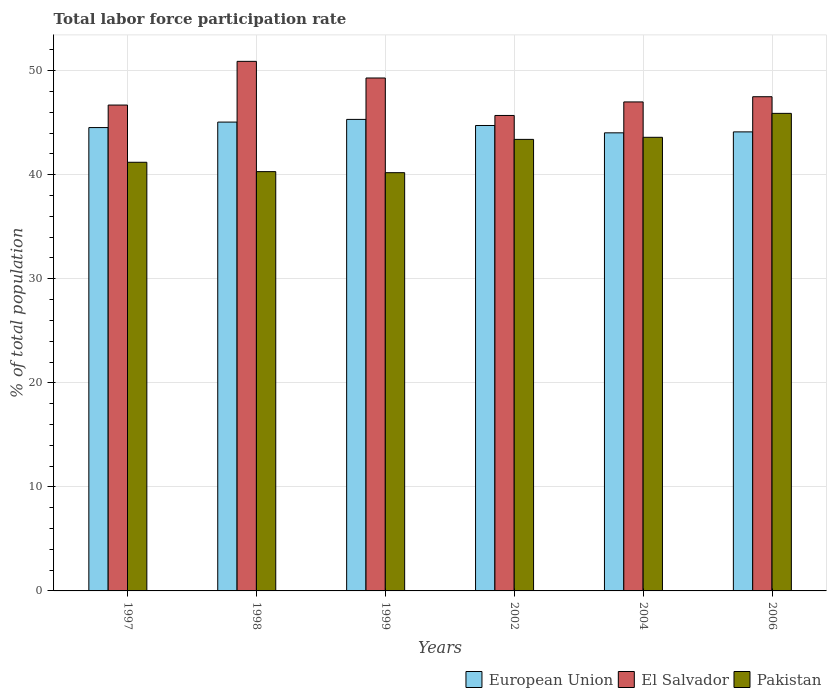Are the number of bars per tick equal to the number of legend labels?
Provide a succinct answer. Yes. How many bars are there on the 2nd tick from the left?
Keep it short and to the point. 3. What is the label of the 5th group of bars from the left?
Ensure brevity in your answer.  2004. In how many cases, is the number of bars for a given year not equal to the number of legend labels?
Offer a terse response. 0. What is the total labor force participation rate in European Union in 1999?
Ensure brevity in your answer.  45.32. Across all years, what is the maximum total labor force participation rate in El Salvador?
Give a very brief answer. 50.9. Across all years, what is the minimum total labor force participation rate in El Salvador?
Ensure brevity in your answer.  45.7. In which year was the total labor force participation rate in Pakistan minimum?
Give a very brief answer. 1999. What is the total total labor force participation rate in El Salvador in the graph?
Give a very brief answer. 287.1. What is the difference between the total labor force participation rate in Pakistan in 1997 and that in 1998?
Provide a short and direct response. 0.9. What is the difference between the total labor force participation rate in Pakistan in 2006 and the total labor force participation rate in European Union in 2004?
Provide a succinct answer. 1.87. What is the average total labor force participation rate in Pakistan per year?
Offer a very short reply. 42.43. In the year 1998, what is the difference between the total labor force participation rate in El Salvador and total labor force participation rate in European Union?
Provide a short and direct response. 5.84. In how many years, is the total labor force participation rate in El Salvador greater than 32 %?
Offer a very short reply. 6. What is the ratio of the total labor force participation rate in Pakistan in 1997 to that in 1998?
Keep it short and to the point. 1.02. Is the difference between the total labor force participation rate in El Salvador in 1998 and 1999 greater than the difference between the total labor force participation rate in European Union in 1998 and 1999?
Offer a very short reply. Yes. What is the difference between the highest and the second highest total labor force participation rate in European Union?
Make the answer very short. 0.26. What is the difference between the highest and the lowest total labor force participation rate in El Salvador?
Your response must be concise. 5.2. In how many years, is the total labor force participation rate in European Union greater than the average total labor force participation rate in European Union taken over all years?
Offer a very short reply. 3. Is the sum of the total labor force participation rate in El Salvador in 1999 and 2006 greater than the maximum total labor force participation rate in Pakistan across all years?
Make the answer very short. Yes. What does the 3rd bar from the left in 2004 represents?
Offer a terse response. Pakistan. What does the 2nd bar from the right in 2006 represents?
Provide a short and direct response. El Salvador. How many bars are there?
Provide a short and direct response. 18. Are the values on the major ticks of Y-axis written in scientific E-notation?
Provide a succinct answer. No. Does the graph contain any zero values?
Give a very brief answer. No. Does the graph contain grids?
Provide a succinct answer. Yes. How are the legend labels stacked?
Provide a short and direct response. Horizontal. What is the title of the graph?
Offer a terse response. Total labor force participation rate. What is the label or title of the Y-axis?
Make the answer very short. % of total population. What is the % of total population of European Union in 1997?
Make the answer very short. 44.54. What is the % of total population of El Salvador in 1997?
Your response must be concise. 46.7. What is the % of total population of Pakistan in 1997?
Provide a succinct answer. 41.2. What is the % of total population in European Union in 1998?
Keep it short and to the point. 45.06. What is the % of total population in El Salvador in 1998?
Offer a terse response. 50.9. What is the % of total population in Pakistan in 1998?
Your response must be concise. 40.3. What is the % of total population in European Union in 1999?
Offer a terse response. 45.32. What is the % of total population in El Salvador in 1999?
Provide a succinct answer. 49.3. What is the % of total population in Pakistan in 1999?
Make the answer very short. 40.2. What is the % of total population of European Union in 2002?
Your answer should be very brief. 44.74. What is the % of total population of El Salvador in 2002?
Your response must be concise. 45.7. What is the % of total population in Pakistan in 2002?
Ensure brevity in your answer.  43.4. What is the % of total population in European Union in 2004?
Offer a terse response. 44.03. What is the % of total population in Pakistan in 2004?
Give a very brief answer. 43.6. What is the % of total population in European Union in 2006?
Keep it short and to the point. 44.12. What is the % of total population of El Salvador in 2006?
Your answer should be very brief. 47.5. What is the % of total population of Pakistan in 2006?
Keep it short and to the point. 45.9. Across all years, what is the maximum % of total population in European Union?
Your response must be concise. 45.32. Across all years, what is the maximum % of total population of El Salvador?
Provide a succinct answer. 50.9. Across all years, what is the maximum % of total population of Pakistan?
Offer a very short reply. 45.9. Across all years, what is the minimum % of total population in European Union?
Provide a short and direct response. 44.03. Across all years, what is the minimum % of total population in El Salvador?
Provide a short and direct response. 45.7. Across all years, what is the minimum % of total population in Pakistan?
Provide a succinct answer. 40.2. What is the total % of total population of European Union in the graph?
Your answer should be compact. 267.81. What is the total % of total population of El Salvador in the graph?
Ensure brevity in your answer.  287.1. What is the total % of total population in Pakistan in the graph?
Give a very brief answer. 254.6. What is the difference between the % of total population in European Union in 1997 and that in 1998?
Your answer should be very brief. -0.53. What is the difference between the % of total population in El Salvador in 1997 and that in 1998?
Offer a very short reply. -4.2. What is the difference between the % of total population of European Union in 1997 and that in 1999?
Give a very brief answer. -0.79. What is the difference between the % of total population in European Union in 1997 and that in 2002?
Provide a succinct answer. -0.2. What is the difference between the % of total population of El Salvador in 1997 and that in 2002?
Offer a terse response. 1. What is the difference between the % of total population of European Union in 1997 and that in 2004?
Ensure brevity in your answer.  0.51. What is the difference between the % of total population in European Union in 1997 and that in 2006?
Your answer should be compact. 0.42. What is the difference between the % of total population in El Salvador in 1997 and that in 2006?
Keep it short and to the point. -0.8. What is the difference between the % of total population in Pakistan in 1997 and that in 2006?
Provide a short and direct response. -4.7. What is the difference between the % of total population of European Union in 1998 and that in 1999?
Ensure brevity in your answer.  -0.26. What is the difference between the % of total population of Pakistan in 1998 and that in 1999?
Offer a very short reply. 0.1. What is the difference between the % of total population of European Union in 1998 and that in 2002?
Your answer should be compact. 0.33. What is the difference between the % of total population of El Salvador in 1998 and that in 2002?
Make the answer very short. 5.2. What is the difference between the % of total population of European Union in 1998 and that in 2004?
Give a very brief answer. 1.03. What is the difference between the % of total population in Pakistan in 1998 and that in 2004?
Provide a succinct answer. -3.3. What is the difference between the % of total population in European Union in 1998 and that in 2006?
Your answer should be compact. 0.94. What is the difference between the % of total population in Pakistan in 1998 and that in 2006?
Offer a terse response. -5.6. What is the difference between the % of total population in European Union in 1999 and that in 2002?
Your response must be concise. 0.59. What is the difference between the % of total population in Pakistan in 1999 and that in 2002?
Offer a very short reply. -3.2. What is the difference between the % of total population in European Union in 1999 and that in 2004?
Ensure brevity in your answer.  1.29. What is the difference between the % of total population in European Union in 1999 and that in 2006?
Ensure brevity in your answer.  1.2. What is the difference between the % of total population in Pakistan in 1999 and that in 2006?
Give a very brief answer. -5.7. What is the difference between the % of total population of European Union in 2002 and that in 2004?
Your answer should be very brief. 0.71. What is the difference between the % of total population in Pakistan in 2002 and that in 2004?
Your response must be concise. -0.2. What is the difference between the % of total population of European Union in 2002 and that in 2006?
Offer a very short reply. 0.62. What is the difference between the % of total population in European Union in 2004 and that in 2006?
Keep it short and to the point. -0.09. What is the difference between the % of total population of European Union in 1997 and the % of total population of El Salvador in 1998?
Make the answer very short. -6.36. What is the difference between the % of total population in European Union in 1997 and the % of total population in Pakistan in 1998?
Offer a terse response. 4.24. What is the difference between the % of total population in European Union in 1997 and the % of total population in El Salvador in 1999?
Give a very brief answer. -4.76. What is the difference between the % of total population in European Union in 1997 and the % of total population in Pakistan in 1999?
Offer a terse response. 4.34. What is the difference between the % of total population in European Union in 1997 and the % of total population in El Salvador in 2002?
Your response must be concise. -1.16. What is the difference between the % of total population of European Union in 1997 and the % of total population of Pakistan in 2002?
Your answer should be compact. 1.14. What is the difference between the % of total population of El Salvador in 1997 and the % of total population of Pakistan in 2002?
Provide a short and direct response. 3.3. What is the difference between the % of total population in European Union in 1997 and the % of total population in El Salvador in 2004?
Your answer should be compact. -2.46. What is the difference between the % of total population in European Union in 1997 and the % of total population in Pakistan in 2004?
Your answer should be very brief. 0.94. What is the difference between the % of total population of El Salvador in 1997 and the % of total population of Pakistan in 2004?
Your response must be concise. 3.1. What is the difference between the % of total population in European Union in 1997 and the % of total population in El Salvador in 2006?
Provide a short and direct response. -2.96. What is the difference between the % of total population in European Union in 1997 and the % of total population in Pakistan in 2006?
Keep it short and to the point. -1.36. What is the difference between the % of total population in European Union in 1998 and the % of total population in El Salvador in 1999?
Make the answer very short. -4.24. What is the difference between the % of total population in European Union in 1998 and the % of total population in Pakistan in 1999?
Your answer should be compact. 4.86. What is the difference between the % of total population of El Salvador in 1998 and the % of total population of Pakistan in 1999?
Provide a short and direct response. 10.7. What is the difference between the % of total population of European Union in 1998 and the % of total population of El Salvador in 2002?
Give a very brief answer. -0.64. What is the difference between the % of total population in European Union in 1998 and the % of total population in Pakistan in 2002?
Ensure brevity in your answer.  1.66. What is the difference between the % of total population in European Union in 1998 and the % of total population in El Salvador in 2004?
Keep it short and to the point. -1.94. What is the difference between the % of total population of European Union in 1998 and the % of total population of Pakistan in 2004?
Ensure brevity in your answer.  1.46. What is the difference between the % of total population of European Union in 1998 and the % of total population of El Salvador in 2006?
Keep it short and to the point. -2.44. What is the difference between the % of total population in European Union in 1998 and the % of total population in Pakistan in 2006?
Your answer should be very brief. -0.84. What is the difference between the % of total population in European Union in 1999 and the % of total population in El Salvador in 2002?
Give a very brief answer. -0.38. What is the difference between the % of total population of European Union in 1999 and the % of total population of Pakistan in 2002?
Provide a short and direct response. 1.92. What is the difference between the % of total population in El Salvador in 1999 and the % of total population in Pakistan in 2002?
Your answer should be very brief. 5.9. What is the difference between the % of total population in European Union in 1999 and the % of total population in El Salvador in 2004?
Your answer should be very brief. -1.68. What is the difference between the % of total population of European Union in 1999 and the % of total population of Pakistan in 2004?
Give a very brief answer. 1.72. What is the difference between the % of total population in European Union in 1999 and the % of total population in El Salvador in 2006?
Ensure brevity in your answer.  -2.18. What is the difference between the % of total population in European Union in 1999 and the % of total population in Pakistan in 2006?
Your answer should be very brief. -0.58. What is the difference between the % of total population of European Union in 2002 and the % of total population of El Salvador in 2004?
Ensure brevity in your answer.  -2.26. What is the difference between the % of total population of European Union in 2002 and the % of total population of Pakistan in 2004?
Ensure brevity in your answer.  1.14. What is the difference between the % of total population in El Salvador in 2002 and the % of total population in Pakistan in 2004?
Ensure brevity in your answer.  2.1. What is the difference between the % of total population of European Union in 2002 and the % of total population of El Salvador in 2006?
Your answer should be very brief. -2.76. What is the difference between the % of total population of European Union in 2002 and the % of total population of Pakistan in 2006?
Provide a short and direct response. -1.16. What is the difference between the % of total population of European Union in 2004 and the % of total population of El Salvador in 2006?
Provide a short and direct response. -3.47. What is the difference between the % of total population in European Union in 2004 and the % of total population in Pakistan in 2006?
Your response must be concise. -1.87. What is the average % of total population in European Union per year?
Your answer should be compact. 44.63. What is the average % of total population in El Salvador per year?
Ensure brevity in your answer.  47.85. What is the average % of total population in Pakistan per year?
Provide a succinct answer. 42.43. In the year 1997, what is the difference between the % of total population in European Union and % of total population in El Salvador?
Make the answer very short. -2.16. In the year 1997, what is the difference between the % of total population of European Union and % of total population of Pakistan?
Ensure brevity in your answer.  3.34. In the year 1997, what is the difference between the % of total population in El Salvador and % of total population in Pakistan?
Provide a succinct answer. 5.5. In the year 1998, what is the difference between the % of total population of European Union and % of total population of El Salvador?
Your answer should be compact. -5.84. In the year 1998, what is the difference between the % of total population in European Union and % of total population in Pakistan?
Your response must be concise. 4.76. In the year 1998, what is the difference between the % of total population of El Salvador and % of total population of Pakistan?
Ensure brevity in your answer.  10.6. In the year 1999, what is the difference between the % of total population in European Union and % of total population in El Salvador?
Provide a short and direct response. -3.98. In the year 1999, what is the difference between the % of total population of European Union and % of total population of Pakistan?
Ensure brevity in your answer.  5.12. In the year 1999, what is the difference between the % of total population of El Salvador and % of total population of Pakistan?
Provide a succinct answer. 9.1. In the year 2002, what is the difference between the % of total population of European Union and % of total population of El Salvador?
Keep it short and to the point. -0.96. In the year 2002, what is the difference between the % of total population in European Union and % of total population in Pakistan?
Offer a terse response. 1.34. In the year 2002, what is the difference between the % of total population in El Salvador and % of total population in Pakistan?
Ensure brevity in your answer.  2.3. In the year 2004, what is the difference between the % of total population in European Union and % of total population in El Salvador?
Give a very brief answer. -2.97. In the year 2004, what is the difference between the % of total population in European Union and % of total population in Pakistan?
Your answer should be compact. 0.43. In the year 2006, what is the difference between the % of total population of European Union and % of total population of El Salvador?
Your response must be concise. -3.38. In the year 2006, what is the difference between the % of total population of European Union and % of total population of Pakistan?
Your response must be concise. -1.78. What is the ratio of the % of total population of European Union in 1997 to that in 1998?
Give a very brief answer. 0.99. What is the ratio of the % of total population in El Salvador in 1997 to that in 1998?
Provide a short and direct response. 0.92. What is the ratio of the % of total population in Pakistan in 1997 to that in 1998?
Give a very brief answer. 1.02. What is the ratio of the % of total population in European Union in 1997 to that in 1999?
Provide a succinct answer. 0.98. What is the ratio of the % of total population in El Salvador in 1997 to that in 1999?
Your answer should be very brief. 0.95. What is the ratio of the % of total population of Pakistan in 1997 to that in 1999?
Your answer should be very brief. 1.02. What is the ratio of the % of total population of European Union in 1997 to that in 2002?
Your response must be concise. 1. What is the ratio of the % of total population in El Salvador in 1997 to that in 2002?
Provide a short and direct response. 1.02. What is the ratio of the % of total population in Pakistan in 1997 to that in 2002?
Your answer should be compact. 0.95. What is the ratio of the % of total population of European Union in 1997 to that in 2004?
Keep it short and to the point. 1.01. What is the ratio of the % of total population in Pakistan in 1997 to that in 2004?
Ensure brevity in your answer.  0.94. What is the ratio of the % of total population in European Union in 1997 to that in 2006?
Your answer should be compact. 1.01. What is the ratio of the % of total population of El Salvador in 1997 to that in 2006?
Offer a very short reply. 0.98. What is the ratio of the % of total population in Pakistan in 1997 to that in 2006?
Offer a terse response. 0.9. What is the ratio of the % of total population of El Salvador in 1998 to that in 1999?
Make the answer very short. 1.03. What is the ratio of the % of total population in Pakistan in 1998 to that in 1999?
Provide a short and direct response. 1. What is the ratio of the % of total population of European Union in 1998 to that in 2002?
Make the answer very short. 1.01. What is the ratio of the % of total population in El Salvador in 1998 to that in 2002?
Give a very brief answer. 1.11. What is the ratio of the % of total population in Pakistan in 1998 to that in 2002?
Your response must be concise. 0.93. What is the ratio of the % of total population in European Union in 1998 to that in 2004?
Offer a very short reply. 1.02. What is the ratio of the % of total population of El Salvador in 1998 to that in 2004?
Make the answer very short. 1.08. What is the ratio of the % of total population in Pakistan in 1998 to that in 2004?
Keep it short and to the point. 0.92. What is the ratio of the % of total population of European Union in 1998 to that in 2006?
Give a very brief answer. 1.02. What is the ratio of the % of total population in El Salvador in 1998 to that in 2006?
Offer a terse response. 1.07. What is the ratio of the % of total population of Pakistan in 1998 to that in 2006?
Offer a terse response. 0.88. What is the ratio of the % of total population of European Union in 1999 to that in 2002?
Your answer should be very brief. 1.01. What is the ratio of the % of total population in El Salvador in 1999 to that in 2002?
Ensure brevity in your answer.  1.08. What is the ratio of the % of total population of Pakistan in 1999 to that in 2002?
Give a very brief answer. 0.93. What is the ratio of the % of total population in European Union in 1999 to that in 2004?
Make the answer very short. 1.03. What is the ratio of the % of total population in El Salvador in 1999 to that in 2004?
Your response must be concise. 1.05. What is the ratio of the % of total population in Pakistan in 1999 to that in 2004?
Offer a terse response. 0.92. What is the ratio of the % of total population in European Union in 1999 to that in 2006?
Your answer should be very brief. 1.03. What is the ratio of the % of total population of El Salvador in 1999 to that in 2006?
Provide a short and direct response. 1.04. What is the ratio of the % of total population in Pakistan in 1999 to that in 2006?
Offer a terse response. 0.88. What is the ratio of the % of total population of European Union in 2002 to that in 2004?
Your answer should be very brief. 1.02. What is the ratio of the % of total population of El Salvador in 2002 to that in 2004?
Keep it short and to the point. 0.97. What is the ratio of the % of total population in Pakistan in 2002 to that in 2004?
Make the answer very short. 1. What is the ratio of the % of total population of European Union in 2002 to that in 2006?
Offer a terse response. 1.01. What is the ratio of the % of total population of El Salvador in 2002 to that in 2006?
Provide a short and direct response. 0.96. What is the ratio of the % of total population in Pakistan in 2002 to that in 2006?
Your response must be concise. 0.95. What is the ratio of the % of total population of Pakistan in 2004 to that in 2006?
Your response must be concise. 0.95. What is the difference between the highest and the second highest % of total population in European Union?
Your answer should be compact. 0.26. What is the difference between the highest and the second highest % of total population of El Salvador?
Offer a terse response. 1.6. What is the difference between the highest and the second highest % of total population of Pakistan?
Your answer should be very brief. 2.3. What is the difference between the highest and the lowest % of total population in European Union?
Offer a very short reply. 1.29. 